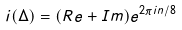<formula> <loc_0><loc_0><loc_500><loc_500>i ( \Delta ) = ( R e + I m ) e ^ { 2 \pi i n / 8 }</formula> 